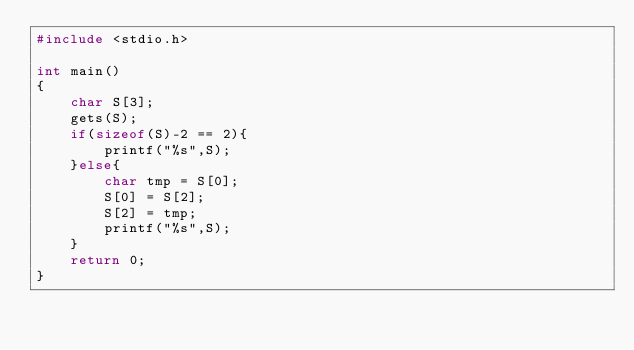<code> <loc_0><loc_0><loc_500><loc_500><_C_>#include <stdio.h>

int main()
{
	char S[3];
	gets(S);
	if(sizeof(S)-2 == 2){
		printf("%s",S);
	}else{
		char tmp = S[0];
		S[0] = S[2];
		S[2] = tmp;
		printf("%s",S);
	}
	return 0;	
}
</code> 